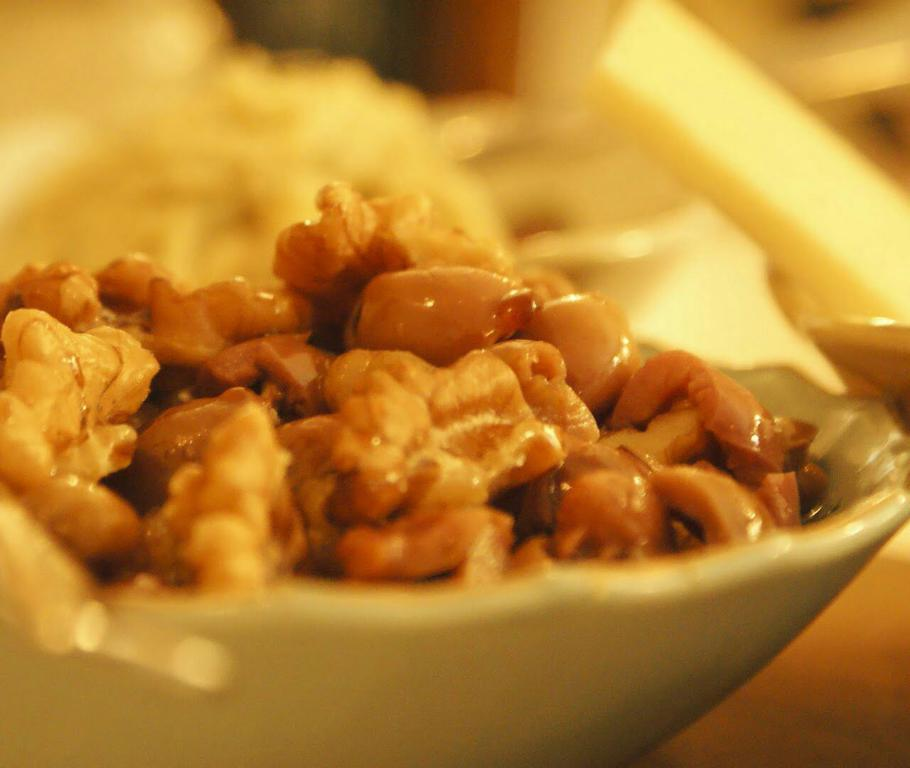What is the main subject of the image? The main subject of the image is a food item in a bowl. Can you describe the bowl in the image? The bowl is on a wooden surface. How is the background of the image depicted? The background of the image is blurred. What type of deer can be seen in the background of the image? There are no deer present in the image; the background is blurred. What recent development has been made in the discovery of this food item? The image does not provide any information about recent developments or discoveries related to the food item. 